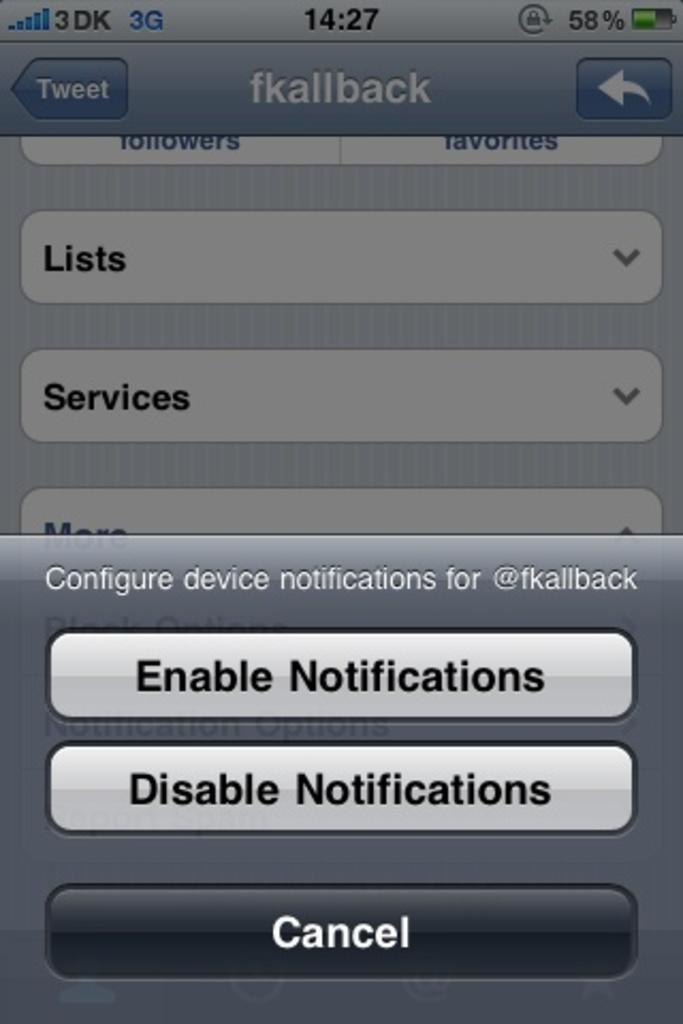<image>
Create a compact narrative representing the image presented. Options for fkallback asks to enable or disable notifications. 